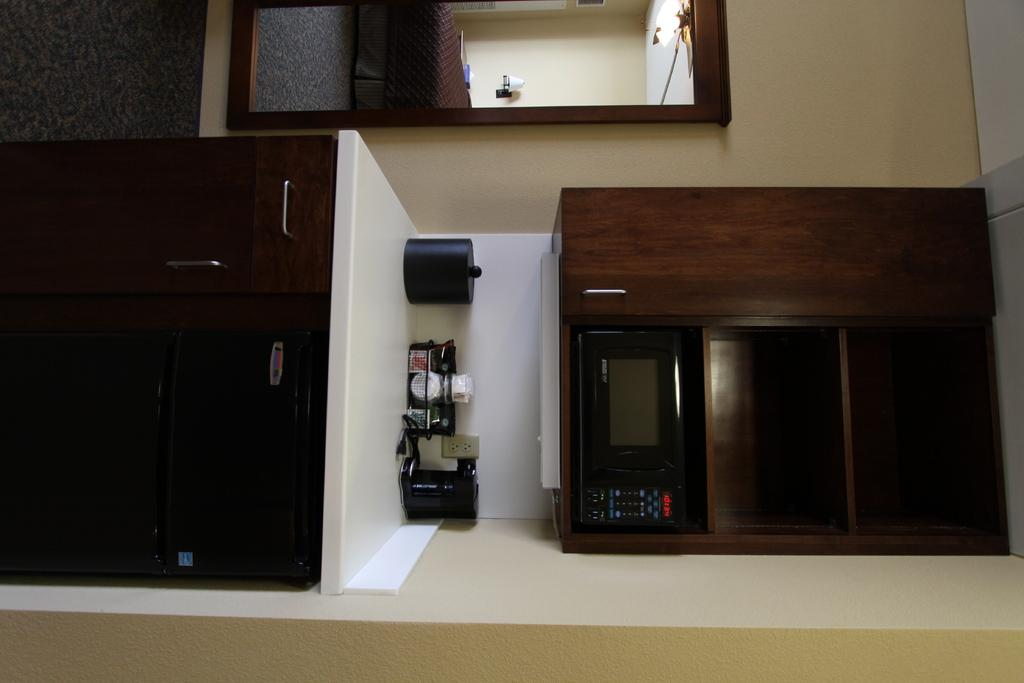What type of furniture is present in the image? There are wooden cupboards in the image. What appliance can be seen in the image? There is an oven in the image. What can be found in the image that is commonly used in a kitchen? Kitchen items are visible in the image. What is the background of the image made of? There is a wall in the image. Is there any entrance or exit in the image? Yes, there is a door in the image. What is used for illumination in the image? There is a light in the image. How many people are sleeping on the back of the yoke in the image? There is no yoke or sleeping people present in the image. 